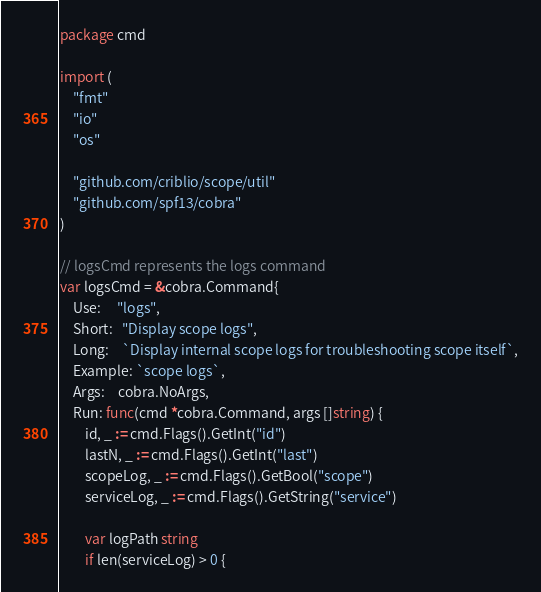<code> <loc_0><loc_0><loc_500><loc_500><_Go_>package cmd

import (
	"fmt"
	"io"
	"os"

	"github.com/criblio/scope/util"
	"github.com/spf13/cobra"
)

// logsCmd represents the logs command
var logsCmd = &cobra.Command{
	Use:     "logs",
	Short:   "Display scope logs",
	Long:    `Display internal scope logs for troubleshooting scope itself`,
	Example: `scope logs`,
	Args:    cobra.NoArgs,
	Run: func(cmd *cobra.Command, args []string) {
		id, _ := cmd.Flags().GetInt("id")
		lastN, _ := cmd.Flags().GetInt("last")
		scopeLog, _ := cmd.Flags().GetBool("scope")
		serviceLog, _ := cmd.Flags().GetString("service")

		var logPath string
		if len(serviceLog) > 0 {</code> 